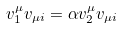<formula> <loc_0><loc_0><loc_500><loc_500>v ^ { \mu } _ { 1 } v _ { \mu i } = \alpha v ^ { \mu } _ { 2 } v _ { \mu i }</formula> 